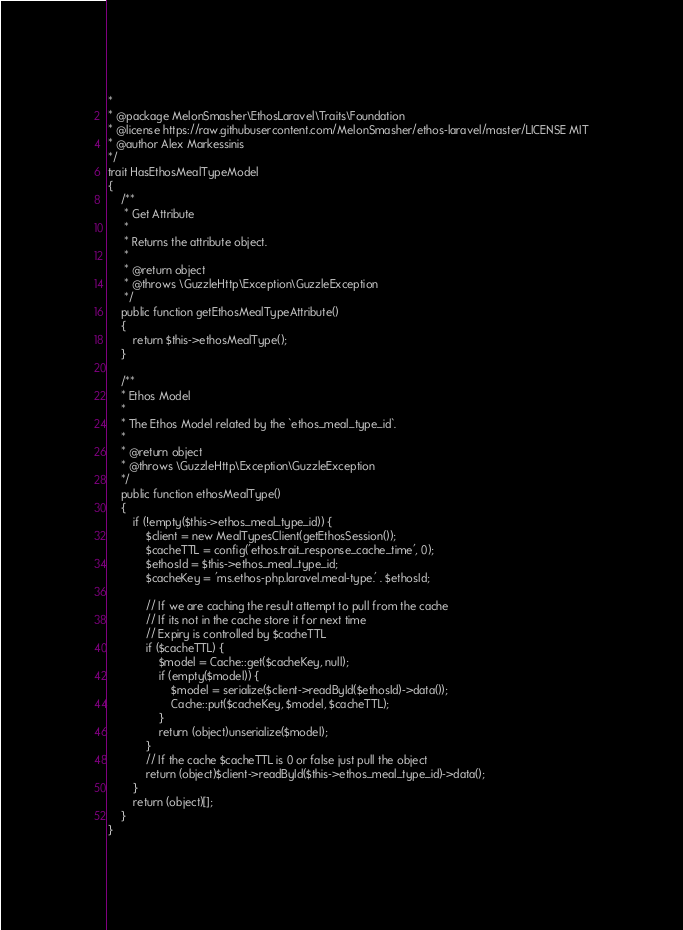<code> <loc_0><loc_0><loc_500><loc_500><_PHP_>*
* @package MelonSmasher\EthosLaravel\Traits\Foundation
* @license https://raw.githubusercontent.com/MelonSmasher/ethos-laravel/master/LICENSE MIT
* @author Alex Markessinis
*/
trait HasEthosMealTypeModel
{
    /**
     * Get Attribute
     *
     * Returns the attribute object.
     *
     * @return object
     * @throws \GuzzleHttp\Exception\GuzzleException
     */
    public function getEthosMealTypeAttribute()
    {
        return $this->ethosMealType();
    }

    /**
    * Ethos Model
    *
    * The Ethos Model related by the `ethos_meal_type_id`.
    *
    * @return object
    * @throws \GuzzleHttp\Exception\GuzzleException
    */
    public function ethosMealType()
    {
        if (!empty($this->ethos_meal_type_id)) {
            $client = new MealTypesClient(getEthosSession());
            $cacheTTL = config('ethos.trait_response_cache_time', 0);
            $ethosId = $this->ethos_meal_type_id;
            $cacheKey = 'ms.ethos-php.laravel.meal-type.' . $ethosId;

            // If we are caching the result attempt to pull from the cache
            // If its not in the cache store it for next time
            // Expiry is controlled by $cacheTTL
            if ($cacheTTL) {
                $model = Cache::get($cacheKey, null);
                if (empty($model)) {
                    $model = serialize($client->readById($ethosId)->data());
                    Cache::put($cacheKey, $model, $cacheTTL);
                }
                return (object)unserialize($model);
            }
            // If the cache $cacheTTL is 0 or false just pull the object
            return (object)$client->readById($this->ethos_meal_type_id)->data();
        }
        return (object)[];
    }
}</code> 